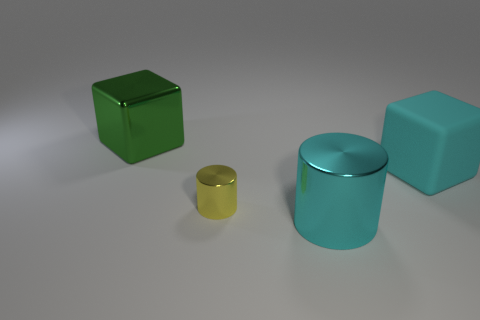How would you describe the arrangement of these objects? The objects are spaced out across a flat surface, seemingly arranged with no particular pattern. Their placement gives the scene an organized yet random feel, with room for each object to stand out individually. Does the arrangement tell us anything about the objects' use or purpose? Without context, it's difficult to infer their use or purpose. The arrangement might be for display, suggesting that they are not in active use but rather positioned for visual or aesthetic examination. 